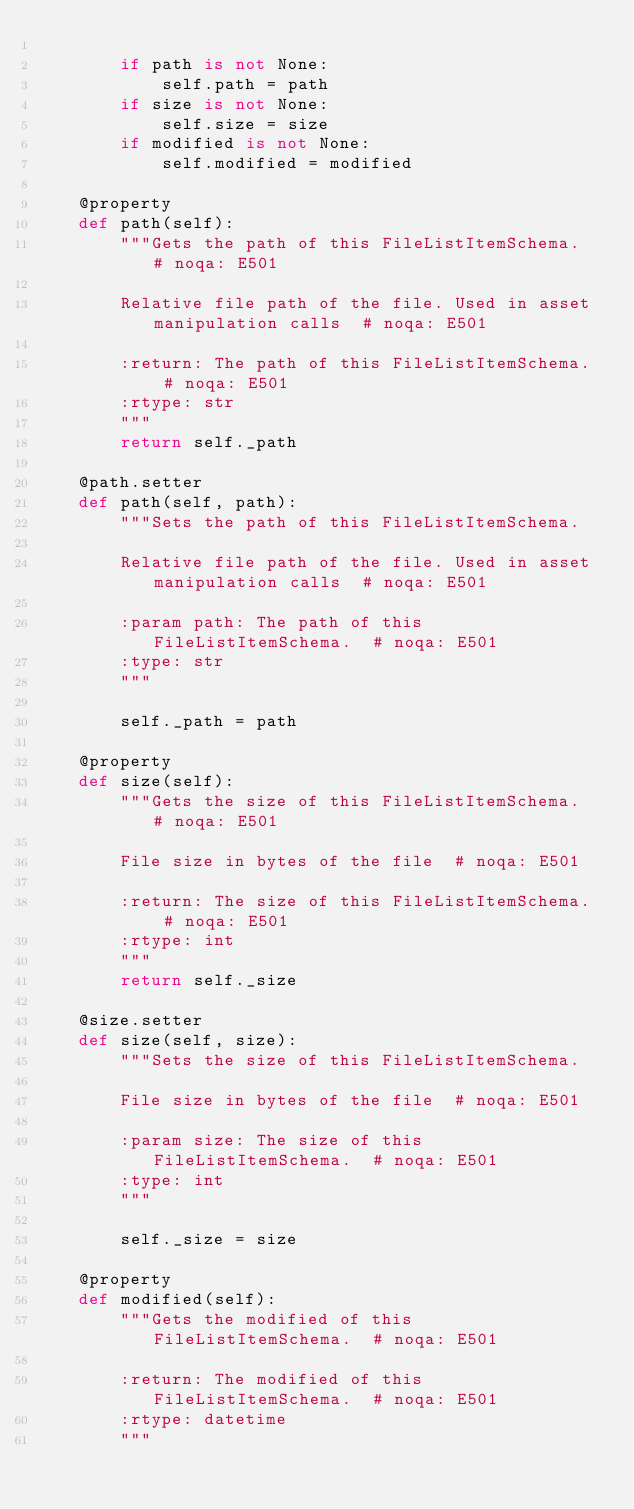<code> <loc_0><loc_0><loc_500><loc_500><_Python_>
        if path is not None:
            self.path = path
        if size is not None:
            self.size = size
        if modified is not None:
            self.modified = modified

    @property
    def path(self):
        """Gets the path of this FileListItemSchema.  # noqa: E501

        Relative file path of the file. Used in asset manipulation calls  # noqa: E501

        :return: The path of this FileListItemSchema.  # noqa: E501
        :rtype: str
        """
        return self._path

    @path.setter
    def path(self, path):
        """Sets the path of this FileListItemSchema.

        Relative file path of the file. Used in asset manipulation calls  # noqa: E501

        :param path: The path of this FileListItemSchema.  # noqa: E501
        :type: str
        """

        self._path = path

    @property
    def size(self):
        """Gets the size of this FileListItemSchema.  # noqa: E501

        File size in bytes of the file  # noqa: E501

        :return: The size of this FileListItemSchema.  # noqa: E501
        :rtype: int
        """
        return self._size

    @size.setter
    def size(self, size):
        """Sets the size of this FileListItemSchema.

        File size in bytes of the file  # noqa: E501

        :param size: The size of this FileListItemSchema.  # noqa: E501
        :type: int
        """

        self._size = size

    @property
    def modified(self):
        """Gets the modified of this FileListItemSchema.  # noqa: E501

        :return: The modified of this FileListItemSchema.  # noqa: E501
        :rtype: datetime
        """</code> 